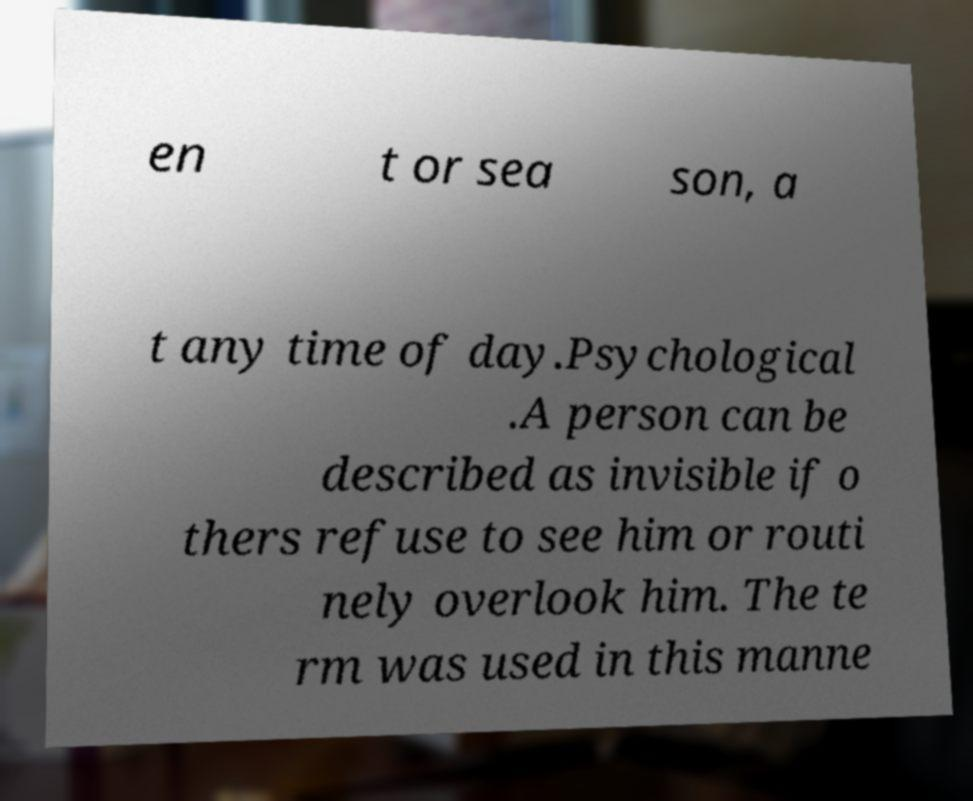Could you assist in decoding the text presented in this image and type it out clearly? en t or sea son, a t any time of day.Psychological .A person can be described as invisible if o thers refuse to see him or routi nely overlook him. The te rm was used in this manne 